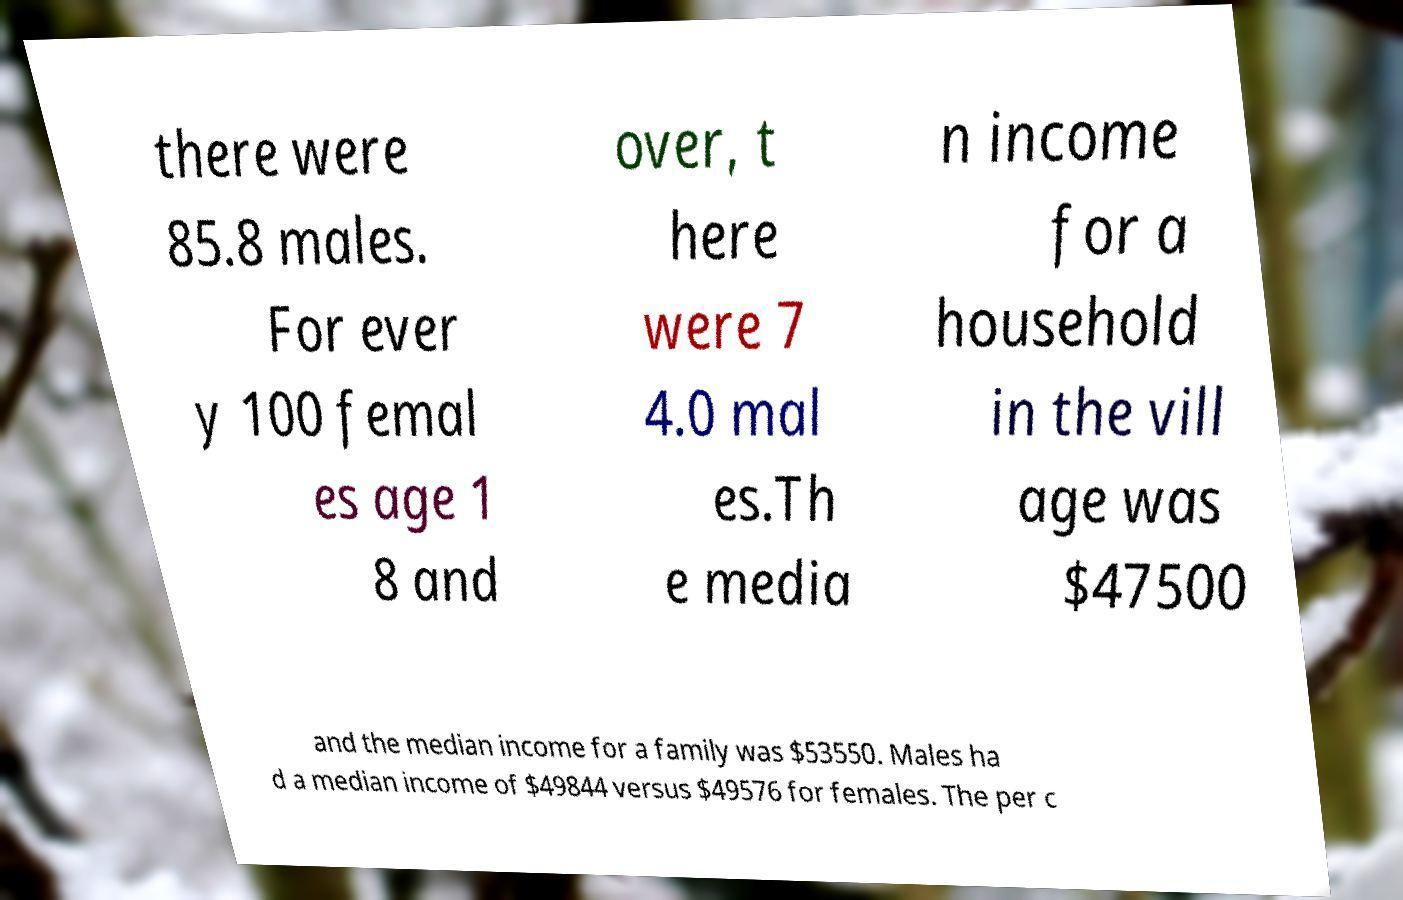For documentation purposes, I need the text within this image transcribed. Could you provide that? there were 85.8 males. For ever y 100 femal es age 1 8 and over, t here were 7 4.0 mal es.Th e media n income for a household in the vill age was $47500 and the median income for a family was $53550. Males ha d a median income of $49844 versus $49576 for females. The per c 